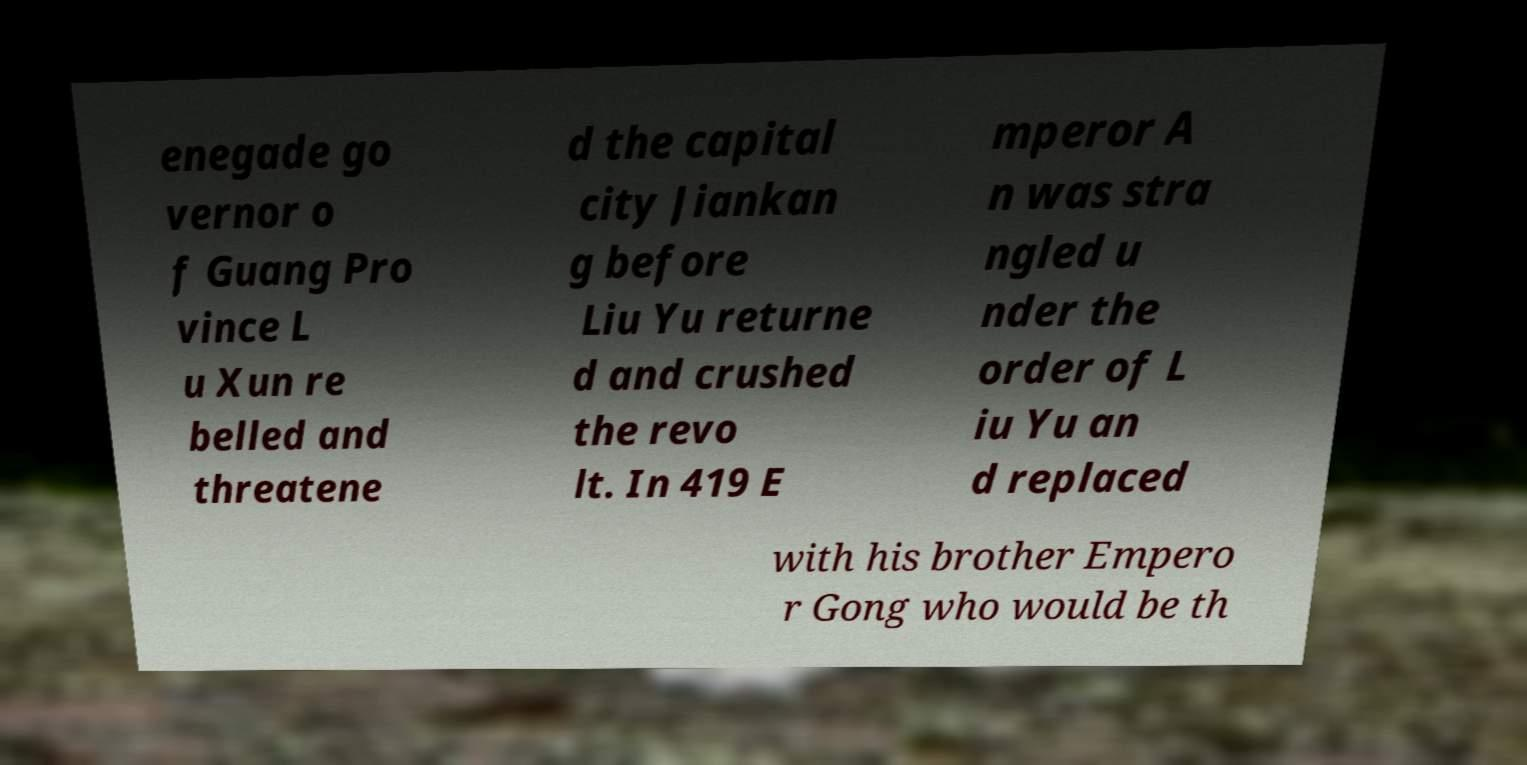For documentation purposes, I need the text within this image transcribed. Could you provide that? enegade go vernor o f Guang Pro vince L u Xun re belled and threatene d the capital city Jiankan g before Liu Yu returne d and crushed the revo lt. In 419 E mperor A n was stra ngled u nder the order of L iu Yu an d replaced with his brother Empero r Gong who would be th 